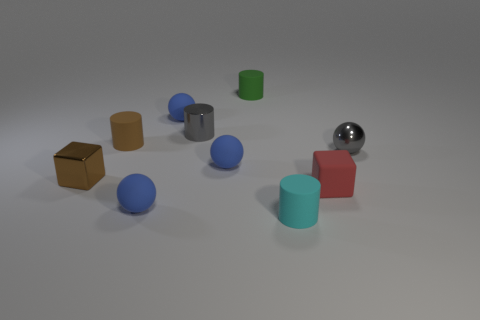Subtract all blue spheres. How many were subtracted if there are2blue spheres left? 1 Subtract all gray cylinders. How many blue balls are left? 3 Subtract all cubes. How many objects are left? 8 Subtract all tiny blue things. Subtract all red things. How many objects are left? 6 Add 8 small brown cubes. How many small brown cubes are left? 9 Add 10 small red shiny blocks. How many small red shiny blocks exist? 10 Subtract 0 green blocks. How many objects are left? 10 